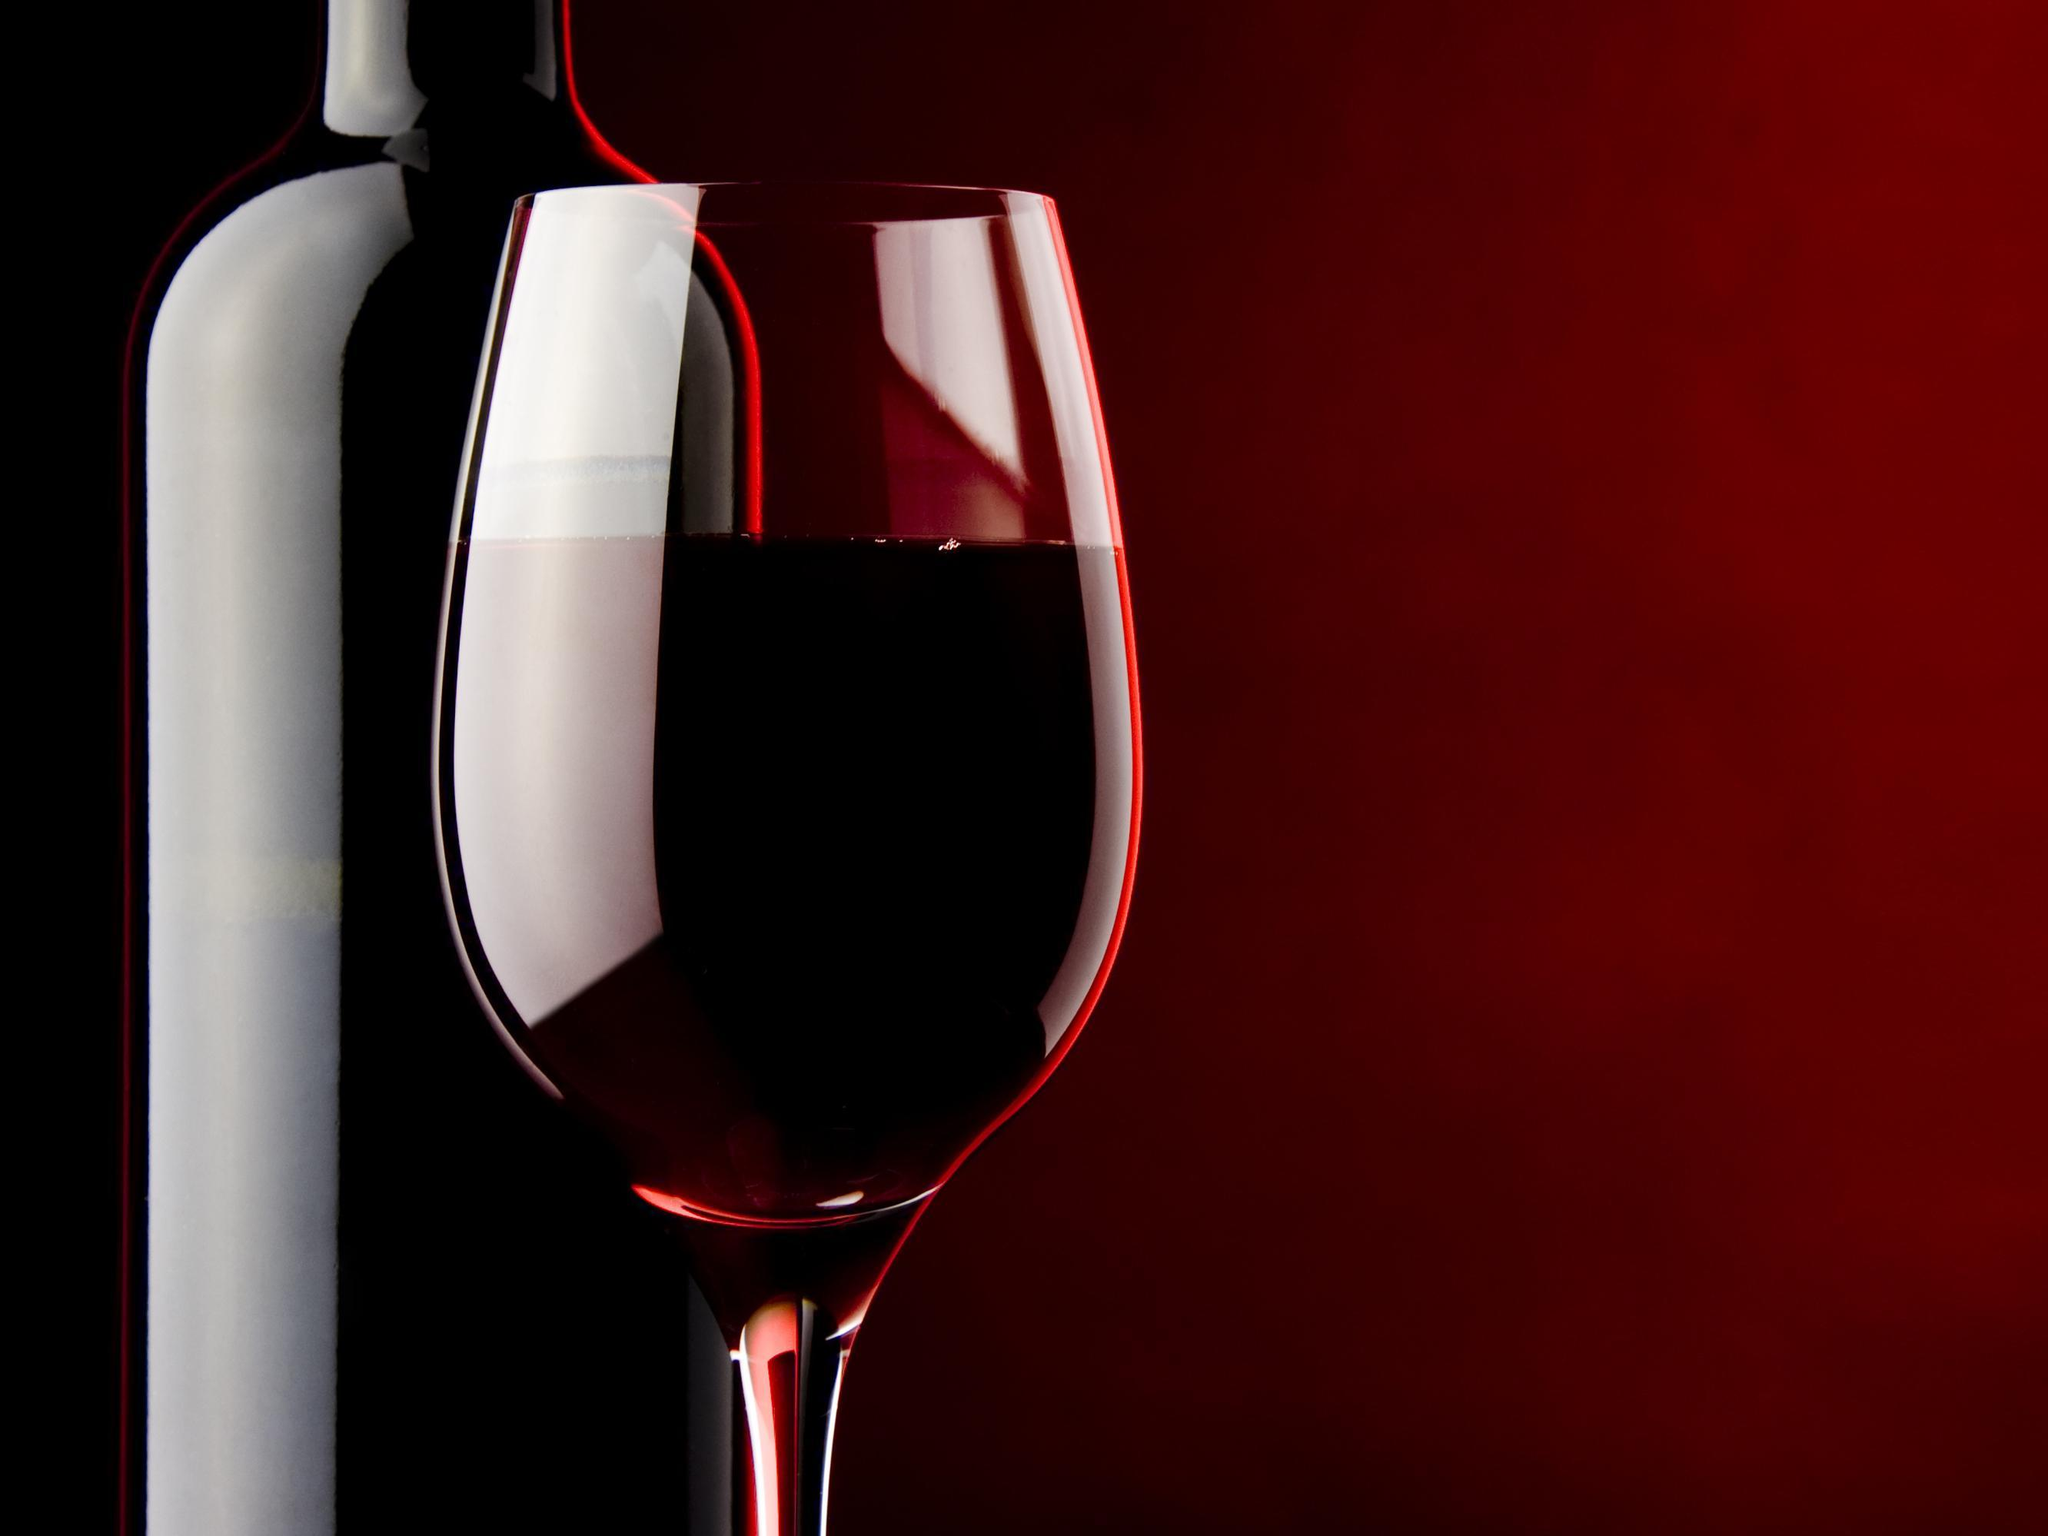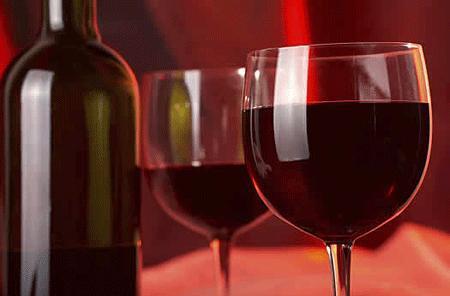The first image is the image on the left, the second image is the image on the right. Examine the images to the left and right. Is the description "There are exactly three glasses filled with red wine" accurate? Answer yes or no. Yes. The first image is the image on the left, the second image is the image on the right. Examine the images to the left and right. Is the description "An image shows wine flowing into a glass, which stands next to an upright bottle." accurate? Answer yes or no. No. 